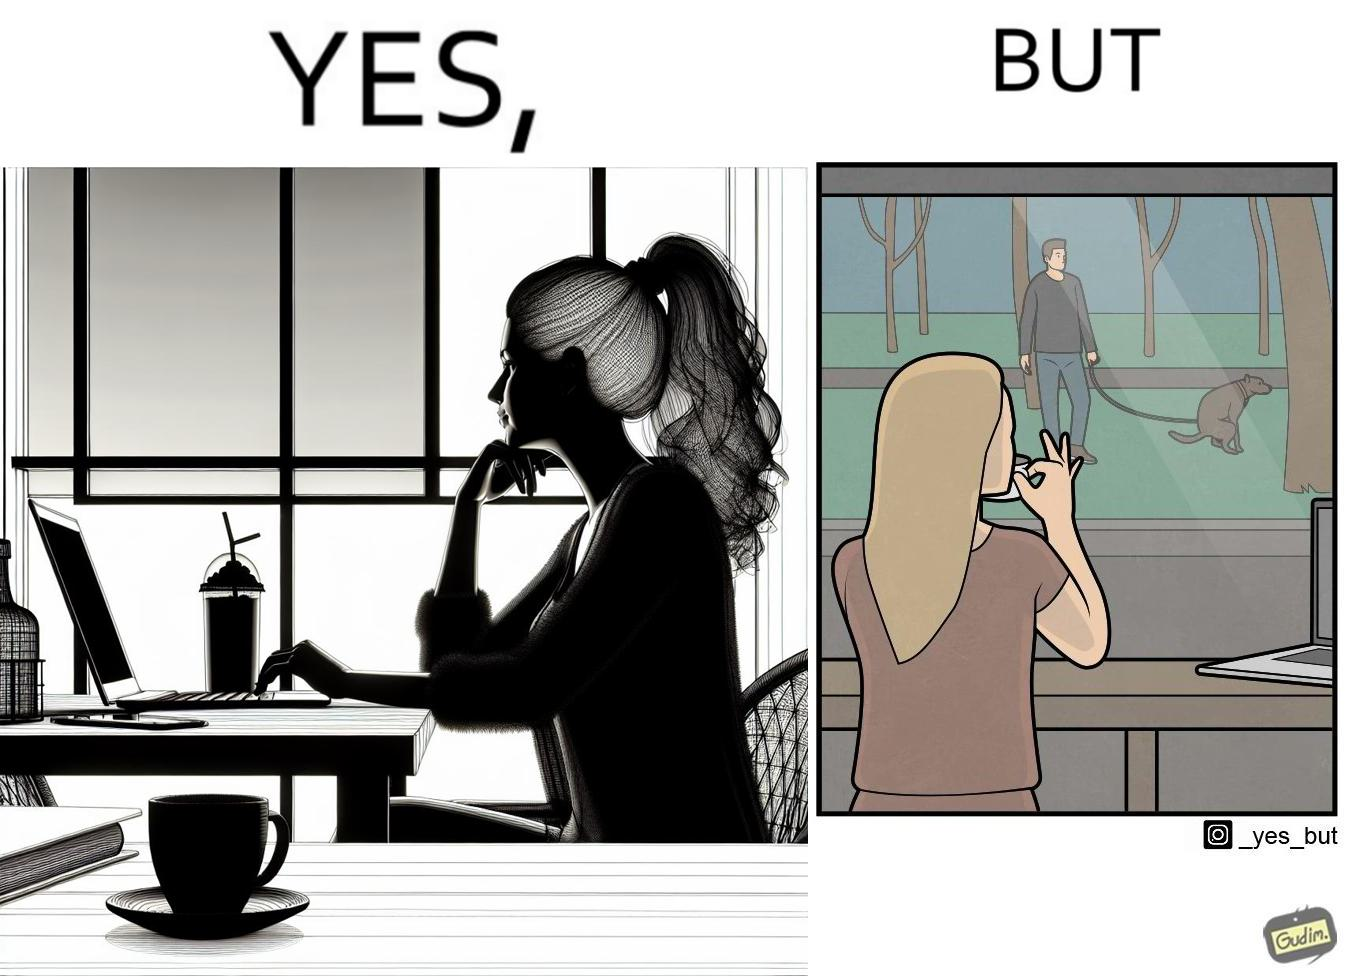What is the satirical meaning behind this image? The image is ironic, because in the first image the woman is seen as enjoying the view but in the second image the same woman is seen as looking at a pooping dog 